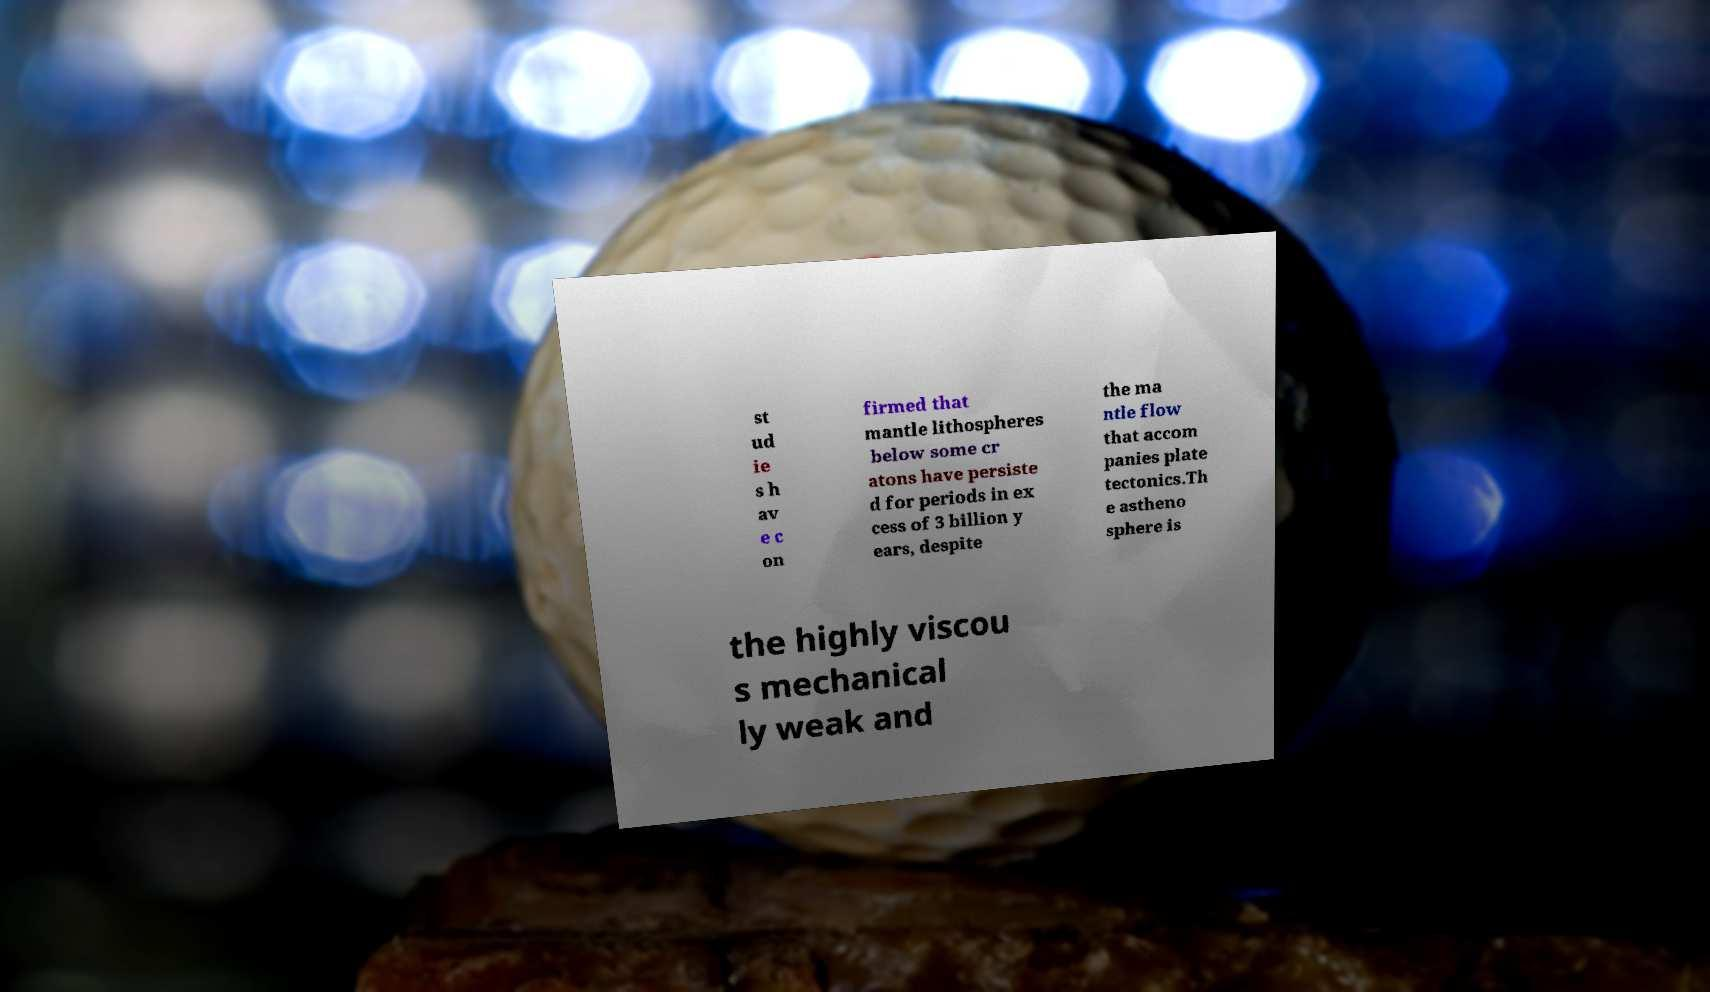What messages or text are displayed in this image? I need them in a readable, typed format. st ud ie s h av e c on firmed that mantle lithospheres below some cr atons have persiste d for periods in ex cess of 3 billion y ears, despite the ma ntle flow that accom panies plate tectonics.Th e astheno sphere is the highly viscou s mechanical ly weak and 